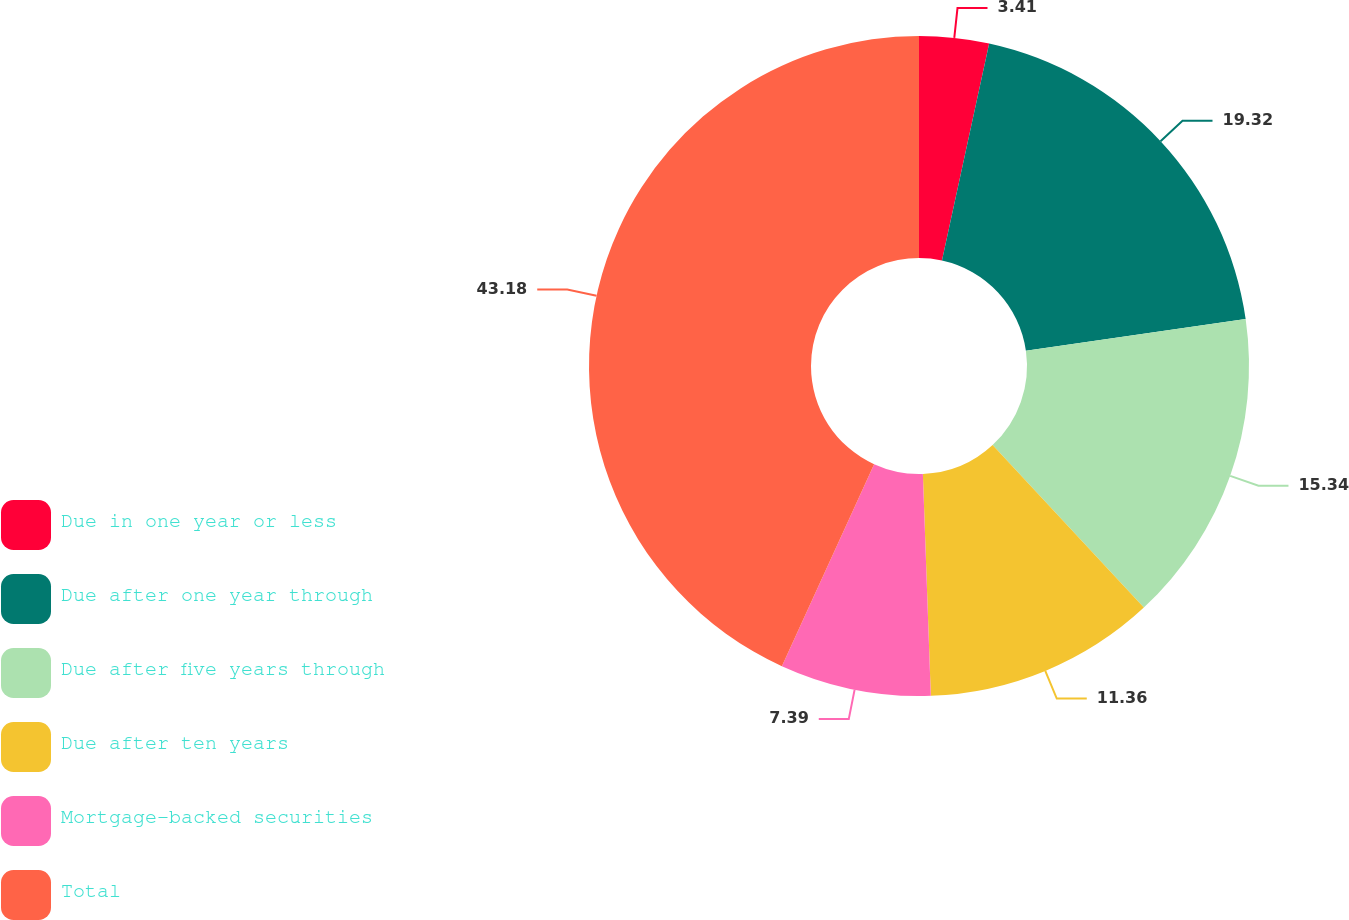Convert chart. <chart><loc_0><loc_0><loc_500><loc_500><pie_chart><fcel>Due in one year or less<fcel>Due after one year through<fcel>Due after five years through<fcel>Due after ten years<fcel>Mortgage-backed securities<fcel>Total<nl><fcel>3.41%<fcel>19.32%<fcel>15.34%<fcel>11.36%<fcel>7.39%<fcel>43.18%<nl></chart> 